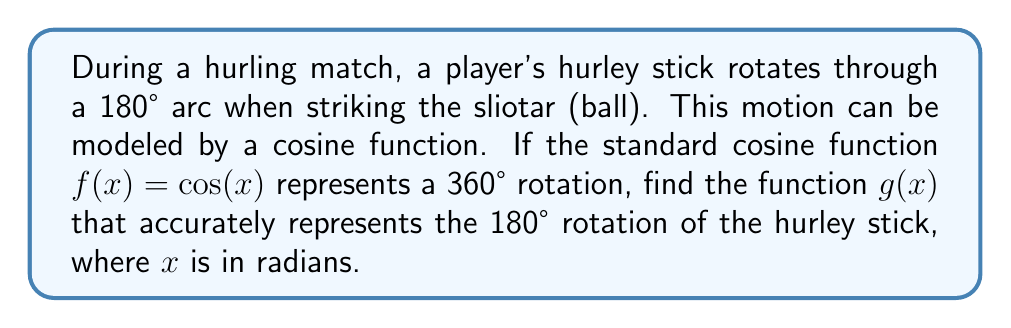Solve this math problem. To solve this problem, we need to scale the cosine function to represent half of its usual period. Let's approach this step-by-step:

1) The standard cosine function $f(x) = \cos(x)$ has a period of $2\pi$ radians, which represents a full 360° rotation.

2) We want to stretch this function horizontally so that one full period (360°) of the original function becomes a half period (180°) in our new function.

3) To achieve this, we need to multiply the input $x$ by a scaling factor. Let's call this factor $k$.

4) We want: $2\pi \cdot k = \pi$ (because $\pi$ radians = 180°)

5) Solving for $k$:
   $k = \frac{\pi}{2\pi} = \frac{1}{2}$

6) Therefore, our new function will be:
   $g(x) = \cos(\frac{1}{2}x)$

7) This function $g(x)$ will complete one full cycle (from 1 to -1 and back to 1) over an input range of $2\pi$ radians, which corresponds to the 180° rotation of the hurley stick.
Answer: $g(x) = \cos(\frac{1}{2}x)$ 